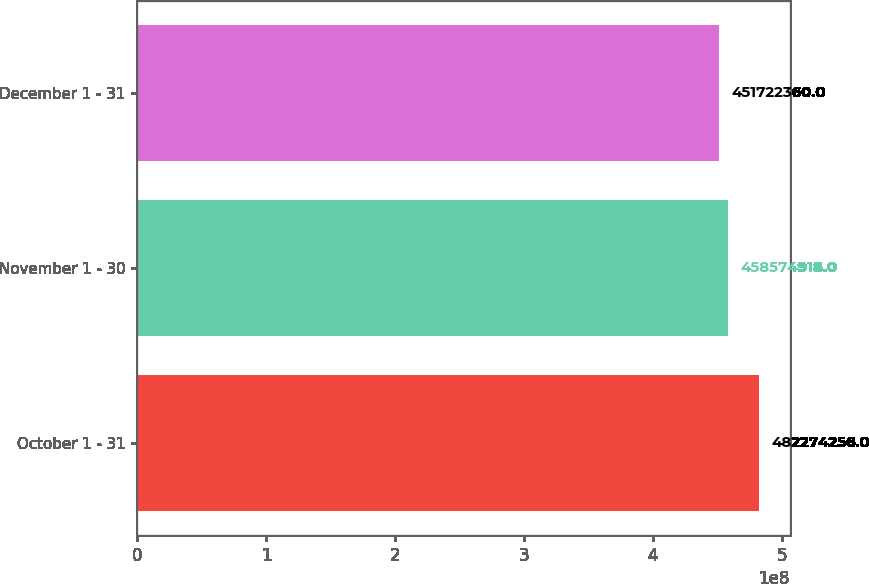Convert chart to OTSL. <chart><loc_0><loc_0><loc_500><loc_500><bar_chart><fcel>October 1 - 31<fcel>November 1 - 30<fcel>December 1 - 31<nl><fcel>4.82274e+08<fcel>4.58575e+08<fcel>4.51722e+08<nl></chart> 